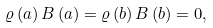Convert formula to latex. <formula><loc_0><loc_0><loc_500><loc_500>\varrho \left ( a \right ) B \left ( a \right ) = \varrho \left ( b \right ) B \left ( b \right ) = 0 ,</formula> 